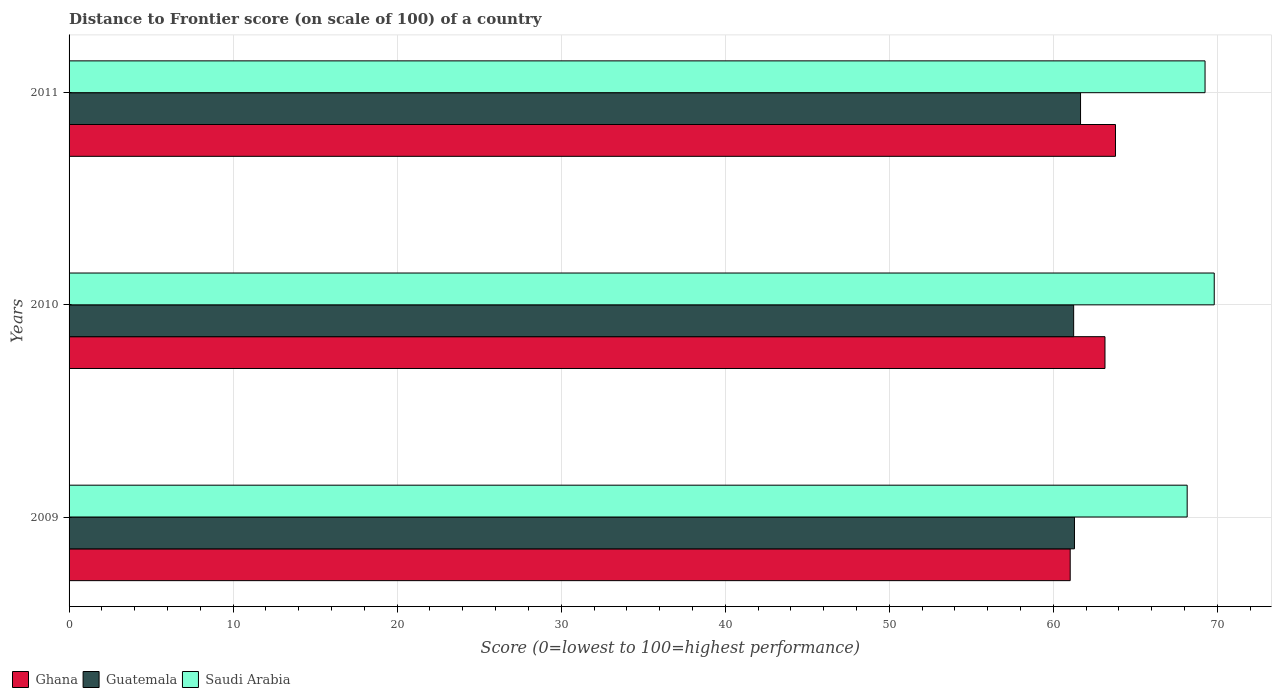How many different coloured bars are there?
Your answer should be very brief. 3. How many groups of bars are there?
Ensure brevity in your answer.  3. What is the label of the 3rd group of bars from the top?
Offer a very short reply. 2009. In how many cases, is the number of bars for a given year not equal to the number of legend labels?
Provide a short and direct response. 0. What is the distance to frontier score of in Ghana in 2009?
Your response must be concise. 61.03. Across all years, what is the maximum distance to frontier score of in Saudi Arabia?
Your answer should be compact. 69.81. Across all years, what is the minimum distance to frontier score of in Saudi Arabia?
Ensure brevity in your answer.  68.16. In which year was the distance to frontier score of in Saudi Arabia maximum?
Offer a terse response. 2010. What is the total distance to frontier score of in Guatemala in the graph?
Keep it short and to the point. 184.19. What is the difference between the distance to frontier score of in Saudi Arabia in 2009 and that in 2010?
Ensure brevity in your answer.  -1.65. What is the difference between the distance to frontier score of in Saudi Arabia in 2010 and the distance to frontier score of in Guatemala in 2009?
Ensure brevity in your answer.  8.52. What is the average distance to frontier score of in Saudi Arabia per year?
Provide a short and direct response. 69.07. In the year 2011, what is the difference between the distance to frontier score of in Saudi Arabia and distance to frontier score of in Guatemala?
Your response must be concise. 7.59. What is the ratio of the distance to frontier score of in Guatemala in 2009 to that in 2010?
Provide a succinct answer. 1. Is the distance to frontier score of in Saudi Arabia in 2009 less than that in 2011?
Offer a terse response. Yes. What is the difference between the highest and the second highest distance to frontier score of in Guatemala?
Ensure brevity in your answer.  0.37. What is the difference between the highest and the lowest distance to frontier score of in Ghana?
Keep it short and to the point. 2.76. What does the 2nd bar from the top in 2009 represents?
Offer a terse response. Guatemala. What does the 3rd bar from the bottom in 2009 represents?
Provide a succinct answer. Saudi Arabia. Is it the case that in every year, the sum of the distance to frontier score of in Guatemala and distance to frontier score of in Ghana is greater than the distance to frontier score of in Saudi Arabia?
Your answer should be compact. Yes. How many bars are there?
Keep it short and to the point. 9. Are all the bars in the graph horizontal?
Keep it short and to the point. Yes. How many years are there in the graph?
Give a very brief answer. 3. Are the values on the major ticks of X-axis written in scientific E-notation?
Your answer should be compact. No. Where does the legend appear in the graph?
Offer a terse response. Bottom left. What is the title of the graph?
Provide a short and direct response. Distance to Frontier score (on scale of 100) of a country. Does "Greenland" appear as one of the legend labels in the graph?
Give a very brief answer. No. What is the label or title of the X-axis?
Ensure brevity in your answer.  Score (0=lowest to 100=highest performance). What is the label or title of the Y-axis?
Make the answer very short. Years. What is the Score (0=lowest to 100=highest performance) of Ghana in 2009?
Make the answer very short. 61.03. What is the Score (0=lowest to 100=highest performance) in Guatemala in 2009?
Your answer should be compact. 61.29. What is the Score (0=lowest to 100=highest performance) in Saudi Arabia in 2009?
Your answer should be very brief. 68.16. What is the Score (0=lowest to 100=highest performance) in Ghana in 2010?
Your answer should be very brief. 63.15. What is the Score (0=lowest to 100=highest performance) of Guatemala in 2010?
Ensure brevity in your answer.  61.24. What is the Score (0=lowest to 100=highest performance) of Saudi Arabia in 2010?
Give a very brief answer. 69.81. What is the Score (0=lowest to 100=highest performance) of Ghana in 2011?
Your answer should be compact. 63.79. What is the Score (0=lowest to 100=highest performance) in Guatemala in 2011?
Provide a short and direct response. 61.66. What is the Score (0=lowest to 100=highest performance) in Saudi Arabia in 2011?
Offer a terse response. 69.25. Across all years, what is the maximum Score (0=lowest to 100=highest performance) in Ghana?
Offer a very short reply. 63.79. Across all years, what is the maximum Score (0=lowest to 100=highest performance) of Guatemala?
Your answer should be compact. 61.66. Across all years, what is the maximum Score (0=lowest to 100=highest performance) of Saudi Arabia?
Keep it short and to the point. 69.81. Across all years, what is the minimum Score (0=lowest to 100=highest performance) in Ghana?
Make the answer very short. 61.03. Across all years, what is the minimum Score (0=lowest to 100=highest performance) of Guatemala?
Provide a short and direct response. 61.24. Across all years, what is the minimum Score (0=lowest to 100=highest performance) in Saudi Arabia?
Your answer should be compact. 68.16. What is the total Score (0=lowest to 100=highest performance) in Ghana in the graph?
Provide a succinct answer. 187.97. What is the total Score (0=lowest to 100=highest performance) of Guatemala in the graph?
Provide a succinct answer. 184.19. What is the total Score (0=lowest to 100=highest performance) in Saudi Arabia in the graph?
Keep it short and to the point. 207.22. What is the difference between the Score (0=lowest to 100=highest performance) in Ghana in 2009 and that in 2010?
Make the answer very short. -2.12. What is the difference between the Score (0=lowest to 100=highest performance) of Saudi Arabia in 2009 and that in 2010?
Ensure brevity in your answer.  -1.65. What is the difference between the Score (0=lowest to 100=highest performance) of Ghana in 2009 and that in 2011?
Keep it short and to the point. -2.76. What is the difference between the Score (0=lowest to 100=highest performance) of Guatemala in 2009 and that in 2011?
Your response must be concise. -0.37. What is the difference between the Score (0=lowest to 100=highest performance) of Saudi Arabia in 2009 and that in 2011?
Provide a short and direct response. -1.09. What is the difference between the Score (0=lowest to 100=highest performance) of Ghana in 2010 and that in 2011?
Keep it short and to the point. -0.64. What is the difference between the Score (0=lowest to 100=highest performance) in Guatemala in 2010 and that in 2011?
Your response must be concise. -0.42. What is the difference between the Score (0=lowest to 100=highest performance) in Saudi Arabia in 2010 and that in 2011?
Ensure brevity in your answer.  0.56. What is the difference between the Score (0=lowest to 100=highest performance) of Ghana in 2009 and the Score (0=lowest to 100=highest performance) of Guatemala in 2010?
Offer a terse response. -0.21. What is the difference between the Score (0=lowest to 100=highest performance) of Ghana in 2009 and the Score (0=lowest to 100=highest performance) of Saudi Arabia in 2010?
Make the answer very short. -8.78. What is the difference between the Score (0=lowest to 100=highest performance) of Guatemala in 2009 and the Score (0=lowest to 100=highest performance) of Saudi Arabia in 2010?
Ensure brevity in your answer.  -8.52. What is the difference between the Score (0=lowest to 100=highest performance) in Ghana in 2009 and the Score (0=lowest to 100=highest performance) in Guatemala in 2011?
Offer a terse response. -0.63. What is the difference between the Score (0=lowest to 100=highest performance) in Ghana in 2009 and the Score (0=lowest to 100=highest performance) in Saudi Arabia in 2011?
Give a very brief answer. -8.22. What is the difference between the Score (0=lowest to 100=highest performance) in Guatemala in 2009 and the Score (0=lowest to 100=highest performance) in Saudi Arabia in 2011?
Provide a succinct answer. -7.96. What is the difference between the Score (0=lowest to 100=highest performance) in Ghana in 2010 and the Score (0=lowest to 100=highest performance) in Guatemala in 2011?
Provide a short and direct response. 1.49. What is the difference between the Score (0=lowest to 100=highest performance) of Ghana in 2010 and the Score (0=lowest to 100=highest performance) of Saudi Arabia in 2011?
Keep it short and to the point. -6.1. What is the difference between the Score (0=lowest to 100=highest performance) in Guatemala in 2010 and the Score (0=lowest to 100=highest performance) in Saudi Arabia in 2011?
Offer a very short reply. -8.01. What is the average Score (0=lowest to 100=highest performance) in Ghana per year?
Make the answer very short. 62.66. What is the average Score (0=lowest to 100=highest performance) in Guatemala per year?
Your answer should be very brief. 61.4. What is the average Score (0=lowest to 100=highest performance) of Saudi Arabia per year?
Offer a very short reply. 69.07. In the year 2009, what is the difference between the Score (0=lowest to 100=highest performance) of Ghana and Score (0=lowest to 100=highest performance) of Guatemala?
Keep it short and to the point. -0.26. In the year 2009, what is the difference between the Score (0=lowest to 100=highest performance) in Ghana and Score (0=lowest to 100=highest performance) in Saudi Arabia?
Offer a terse response. -7.13. In the year 2009, what is the difference between the Score (0=lowest to 100=highest performance) of Guatemala and Score (0=lowest to 100=highest performance) of Saudi Arabia?
Give a very brief answer. -6.87. In the year 2010, what is the difference between the Score (0=lowest to 100=highest performance) of Ghana and Score (0=lowest to 100=highest performance) of Guatemala?
Offer a very short reply. 1.91. In the year 2010, what is the difference between the Score (0=lowest to 100=highest performance) of Ghana and Score (0=lowest to 100=highest performance) of Saudi Arabia?
Your answer should be compact. -6.66. In the year 2010, what is the difference between the Score (0=lowest to 100=highest performance) of Guatemala and Score (0=lowest to 100=highest performance) of Saudi Arabia?
Provide a succinct answer. -8.57. In the year 2011, what is the difference between the Score (0=lowest to 100=highest performance) of Ghana and Score (0=lowest to 100=highest performance) of Guatemala?
Your answer should be compact. 2.13. In the year 2011, what is the difference between the Score (0=lowest to 100=highest performance) in Ghana and Score (0=lowest to 100=highest performance) in Saudi Arabia?
Give a very brief answer. -5.46. In the year 2011, what is the difference between the Score (0=lowest to 100=highest performance) of Guatemala and Score (0=lowest to 100=highest performance) of Saudi Arabia?
Keep it short and to the point. -7.59. What is the ratio of the Score (0=lowest to 100=highest performance) of Ghana in 2009 to that in 2010?
Give a very brief answer. 0.97. What is the ratio of the Score (0=lowest to 100=highest performance) of Guatemala in 2009 to that in 2010?
Give a very brief answer. 1. What is the ratio of the Score (0=lowest to 100=highest performance) of Saudi Arabia in 2009 to that in 2010?
Offer a very short reply. 0.98. What is the ratio of the Score (0=lowest to 100=highest performance) of Ghana in 2009 to that in 2011?
Give a very brief answer. 0.96. What is the ratio of the Score (0=lowest to 100=highest performance) in Guatemala in 2009 to that in 2011?
Give a very brief answer. 0.99. What is the ratio of the Score (0=lowest to 100=highest performance) in Saudi Arabia in 2009 to that in 2011?
Provide a succinct answer. 0.98. What is the ratio of the Score (0=lowest to 100=highest performance) of Ghana in 2010 to that in 2011?
Ensure brevity in your answer.  0.99. What is the ratio of the Score (0=lowest to 100=highest performance) in Guatemala in 2010 to that in 2011?
Give a very brief answer. 0.99. What is the ratio of the Score (0=lowest to 100=highest performance) of Saudi Arabia in 2010 to that in 2011?
Give a very brief answer. 1.01. What is the difference between the highest and the second highest Score (0=lowest to 100=highest performance) in Ghana?
Make the answer very short. 0.64. What is the difference between the highest and the second highest Score (0=lowest to 100=highest performance) in Guatemala?
Give a very brief answer. 0.37. What is the difference between the highest and the second highest Score (0=lowest to 100=highest performance) in Saudi Arabia?
Offer a very short reply. 0.56. What is the difference between the highest and the lowest Score (0=lowest to 100=highest performance) of Ghana?
Keep it short and to the point. 2.76. What is the difference between the highest and the lowest Score (0=lowest to 100=highest performance) in Guatemala?
Offer a very short reply. 0.42. What is the difference between the highest and the lowest Score (0=lowest to 100=highest performance) of Saudi Arabia?
Provide a succinct answer. 1.65. 